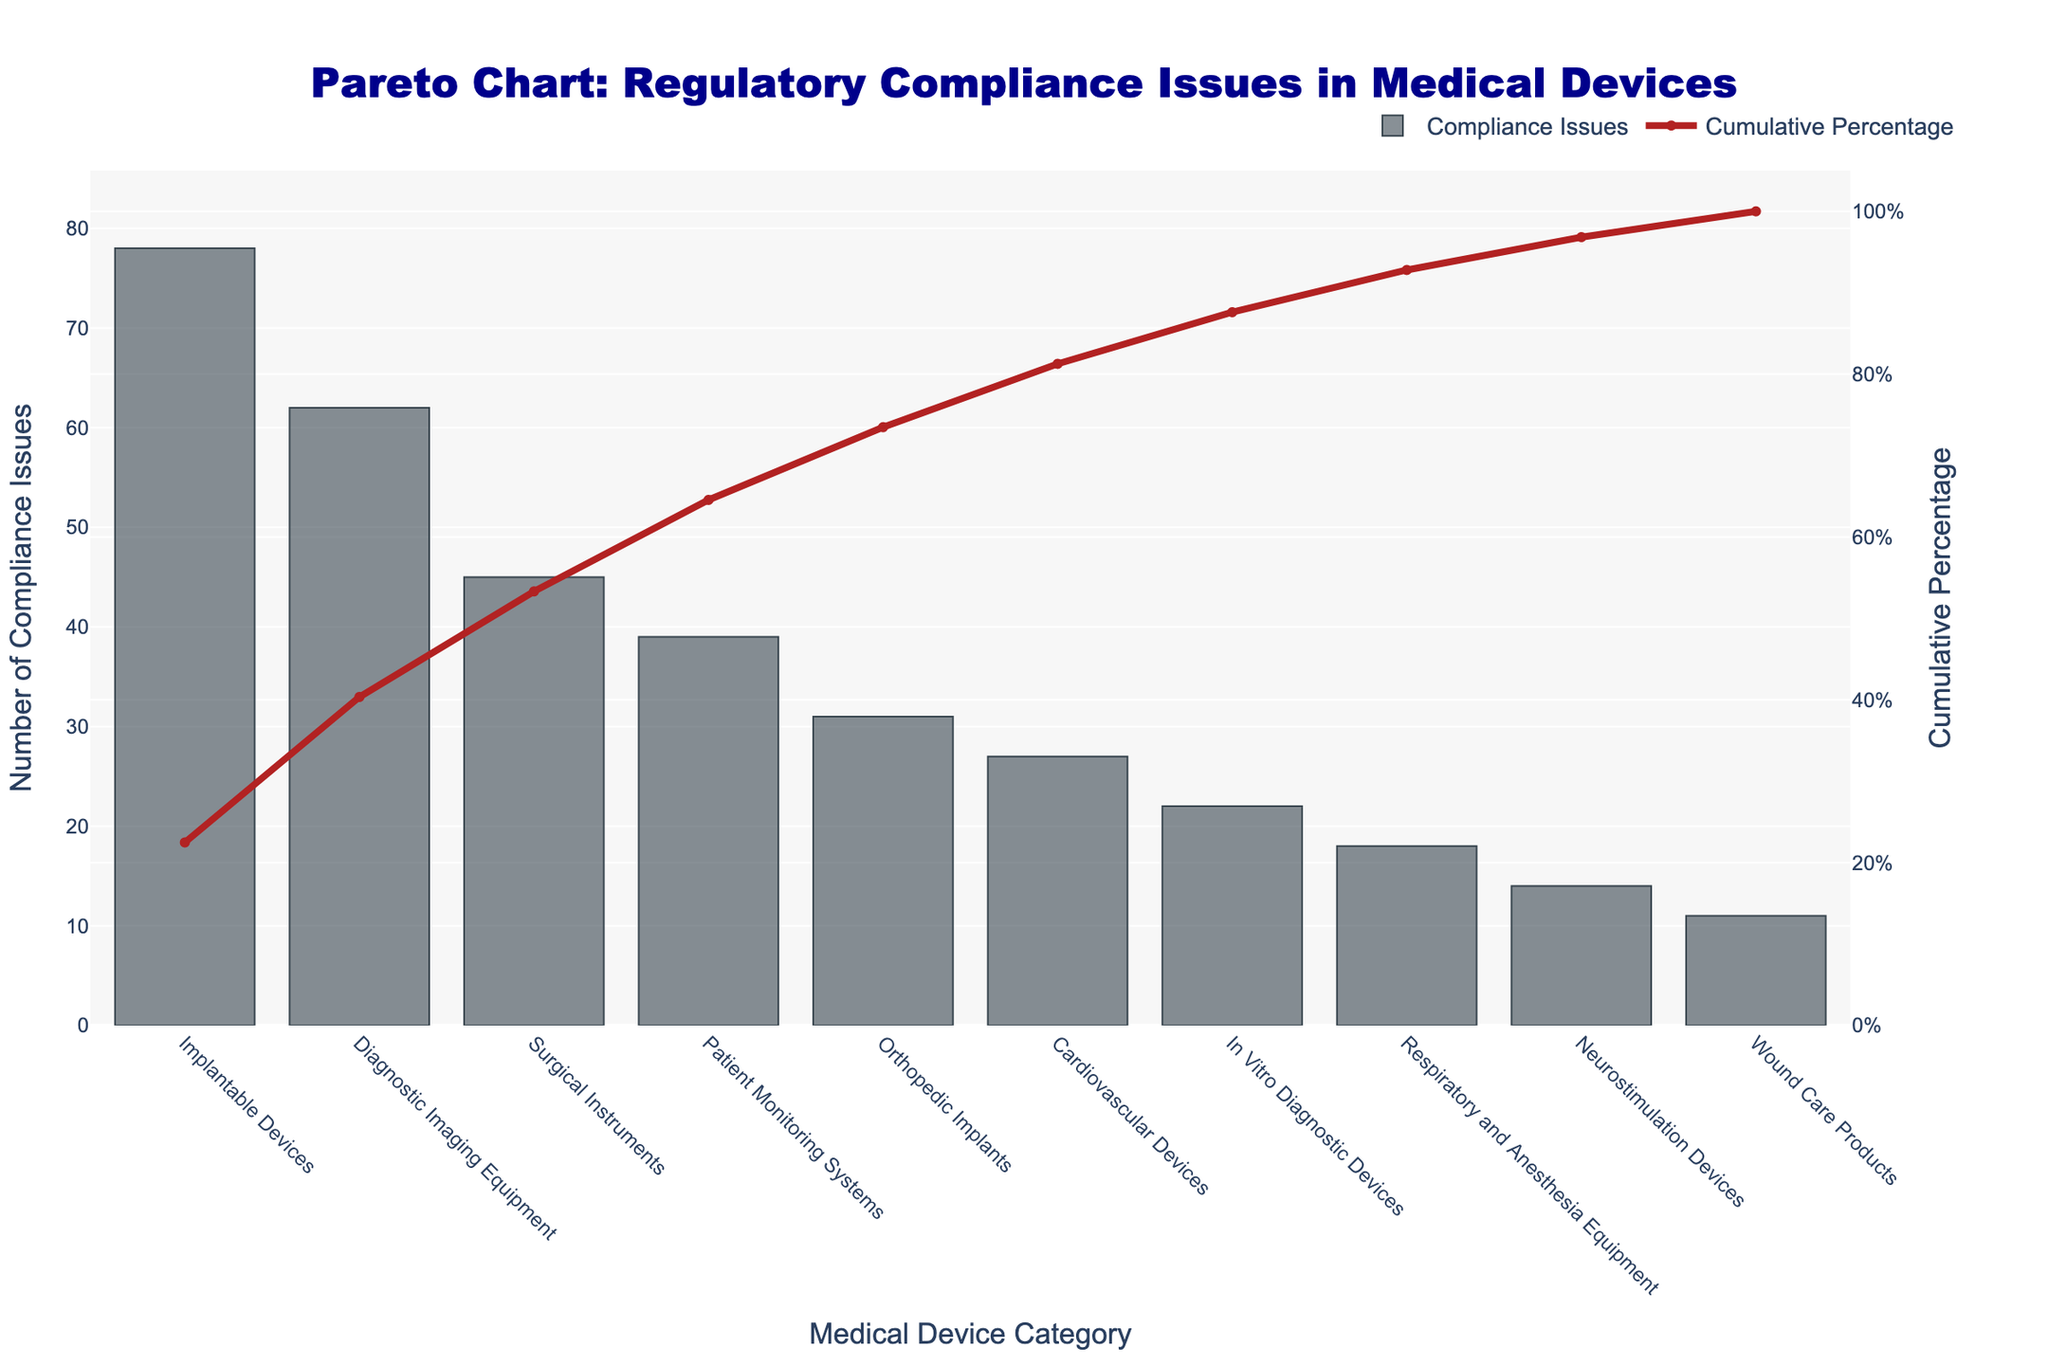What is the title of the Pareto chart? The title is located at the top of the chart and typically provides a brief description of the chart's purpose. In this case, it outlines that the chart shows regulatory compliance issues in medical devices.
Answer: Pareto Chart: Regulatory Compliance Issues in Medical Devices Which medical device category has the highest number of compliance issues? By observing the height of the bars, the tallest bar represents the category with the highest number of compliance issues.
Answer: Implantable Devices What is the cumulative percentage of compliance issues by the third medical device category? The cumulative percentage line plot shows the running total percentage of compliance issues. Sum the values of the first three categories to find this.
Answer: 52.33% How many medical device categories have fewer than 20 compliance issues? Identify the bars that are below the 20-mark on the y-axis.
Answer: Three categories What is the difference in the number of compliance issues between Implantable Devices and Orthopedic Implants? Subtract the number of compliance issues for Orthopedic Implants from the number for Implantable Devices (78 - 31).
Answer: 47 Which category reaches approximately the 50% cumulative percentage? Find the point on the cumulative percentage line where it crosses the 50% mark, and identify the corresponding category below.
Answer: Surgical Instruments Which category marks the steepest increase in cumulative percentage? Observe the cumulative percentage line: the steepest increase is typically associated with the largest single jump in percentage between two consecutive categories.
Answer: Implantable Devices What cumulative percentage do Patient Monitoring Systems contribute to? Locate Patient Monitoring Systems on the x-axis and follow its vertical position to intersect with the cumulative percentage line to find the exact cumulative percentage.
Answer: 70.97% How many categories together make up more than 80% of total compliance issues? Trace the cumulative percentage line until it surpasses 80% and count the number of categories up to this point.
Answer: Five categories Are there any medical device categories with fewer than 15 compliance issues? Compare the heights of the bars against the 15-mark on the y-axis.
Answer: Yes (two categories) Which medical device category has exactly 27 compliance issues, and what is its cumulative percentage? Find the bar with a height of 27 and then refer to the cumulative percentage line for this category.
Answer: Cardiovascular Devices, 87.29% 